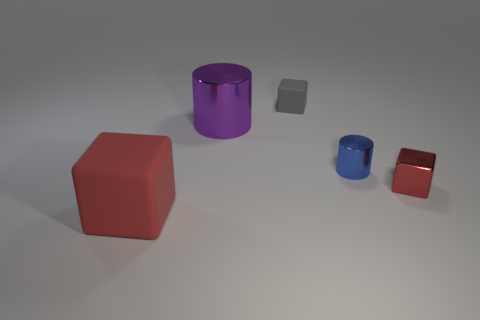Subtract all green spheres. How many red blocks are left? 2 Add 2 big purple cylinders. How many objects exist? 7 Subtract all matte cubes. How many cubes are left? 1 Subtract all cylinders. How many objects are left? 3 Add 1 small shiny cylinders. How many small shiny cylinders are left? 2 Add 5 shiny things. How many shiny things exist? 8 Subtract 0 purple balls. How many objects are left? 5 Subtract all yellow cubes. Subtract all brown spheres. How many cubes are left? 3 Subtract all big cylinders. Subtract all big metallic cylinders. How many objects are left? 3 